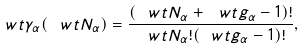Convert formula to latex. <formula><loc_0><loc_0><loc_500><loc_500>\ w t { \gamma } _ { \alpha } ( \ w t { N } _ { \alpha } ) = \frac { ( \ w t { N } _ { \alpha } + \ w t { g } _ { \alpha } - 1 ) ! } { \ w t { N } _ { \alpha } ! ( \ w t { g } _ { \alpha } - 1 ) ! } ,</formula> 